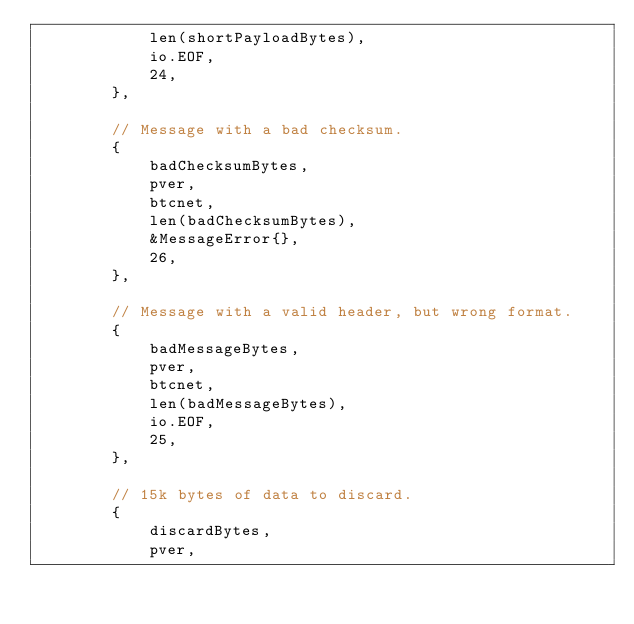<code> <loc_0><loc_0><loc_500><loc_500><_Go_>			len(shortPayloadBytes),
			io.EOF,
			24,
		},

		// Message with a bad checksum.
		{
			badChecksumBytes,
			pver,
			btcnet,
			len(badChecksumBytes),
			&MessageError{},
			26,
		},

		// Message with a valid header, but wrong format.
		{
			badMessageBytes,
			pver,
			btcnet,
			len(badMessageBytes),
			io.EOF,
			25,
		},

		// 15k bytes of data to discard.
		{
			discardBytes,
			pver,</code> 